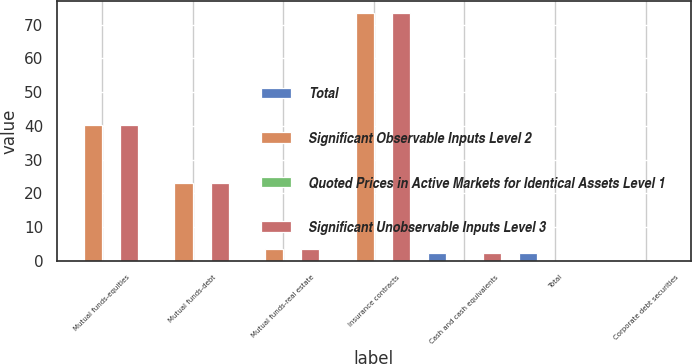<chart> <loc_0><loc_0><loc_500><loc_500><stacked_bar_chart><ecel><fcel>Mutual funds-equities<fcel>Mutual funds-debt<fcel>Mutual funds-real estate<fcel>Insurance contracts<fcel>Cash and cash equivalents<fcel>Total<fcel>Corporate debt securities<nl><fcel>Total<fcel>0<fcel>0<fcel>0<fcel>0<fcel>2.3<fcel>2.3<fcel>0.1<nl><fcel>Significant Observable Inputs Level 2<fcel>40.3<fcel>23.2<fcel>3.5<fcel>73.3<fcel>0<fcel>0.05<fcel>0<nl><fcel>Quoted Prices in Active Markets for Identical Assets Level 1<fcel>0<fcel>0<fcel>0<fcel>0<fcel>0<fcel>0<fcel>0<nl><fcel>Significant Unobservable Inputs Level 3<fcel>40.3<fcel>23.2<fcel>3.5<fcel>73.3<fcel>2.3<fcel>0.05<fcel>0.1<nl></chart> 